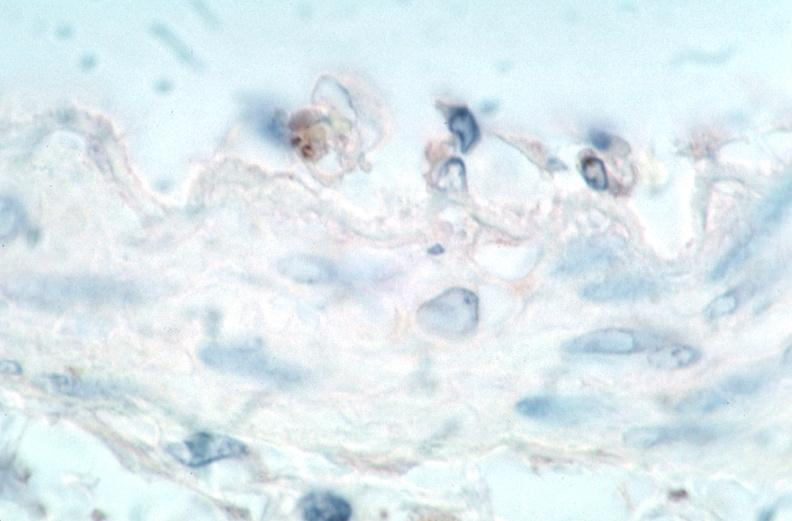s cardiovascular present?
Answer the question using a single word or phrase. Yes 